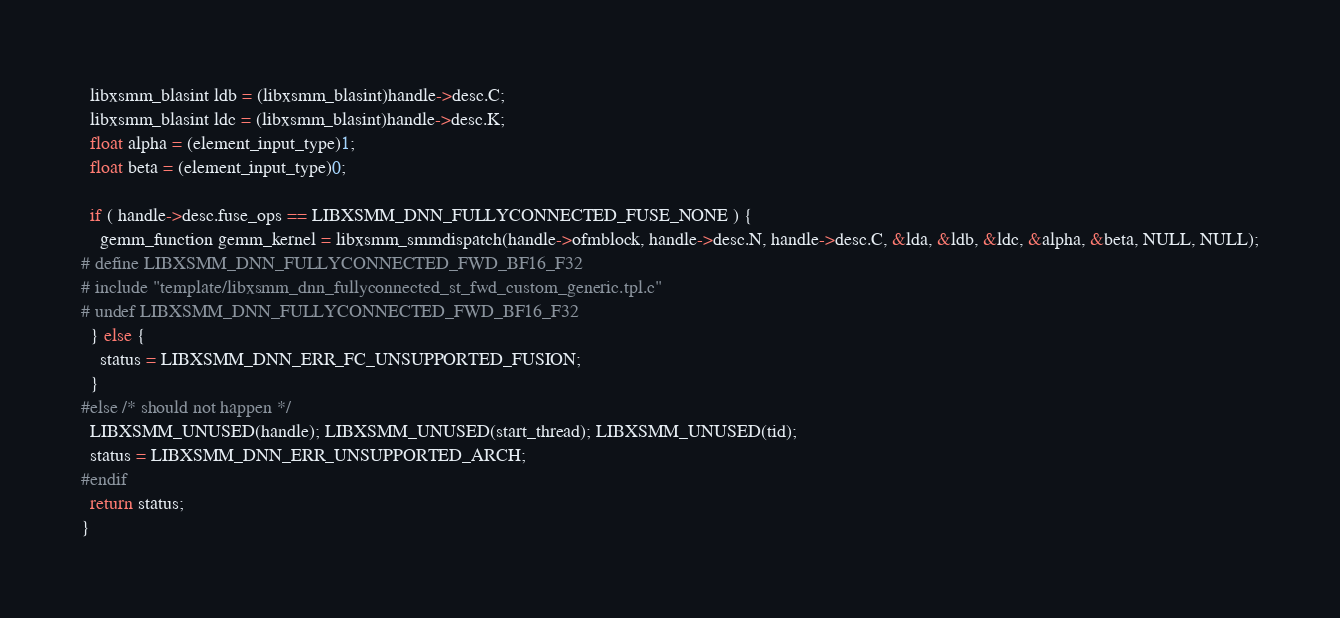Convert code to text. <code><loc_0><loc_0><loc_500><loc_500><_C_>  libxsmm_blasint ldb = (libxsmm_blasint)handle->desc.C;
  libxsmm_blasint ldc = (libxsmm_blasint)handle->desc.K;
  float alpha = (element_input_type)1;
  float beta = (element_input_type)0;

  if ( handle->desc.fuse_ops == LIBXSMM_DNN_FULLYCONNECTED_FUSE_NONE ) {
    gemm_function gemm_kernel = libxsmm_smmdispatch(handle->ofmblock, handle->desc.N, handle->desc.C, &lda, &ldb, &ldc, &alpha, &beta, NULL, NULL);
# define LIBXSMM_DNN_FULLYCONNECTED_FWD_BF16_F32
# include "template/libxsmm_dnn_fullyconnected_st_fwd_custom_generic.tpl.c"
# undef LIBXSMM_DNN_FULLYCONNECTED_FWD_BF16_F32
  } else {
    status = LIBXSMM_DNN_ERR_FC_UNSUPPORTED_FUSION;
  }
#else /* should not happen */
  LIBXSMM_UNUSED(handle); LIBXSMM_UNUSED(start_thread); LIBXSMM_UNUSED(tid);
  status = LIBXSMM_DNN_ERR_UNSUPPORTED_ARCH;
#endif
  return status;
}

</code> 